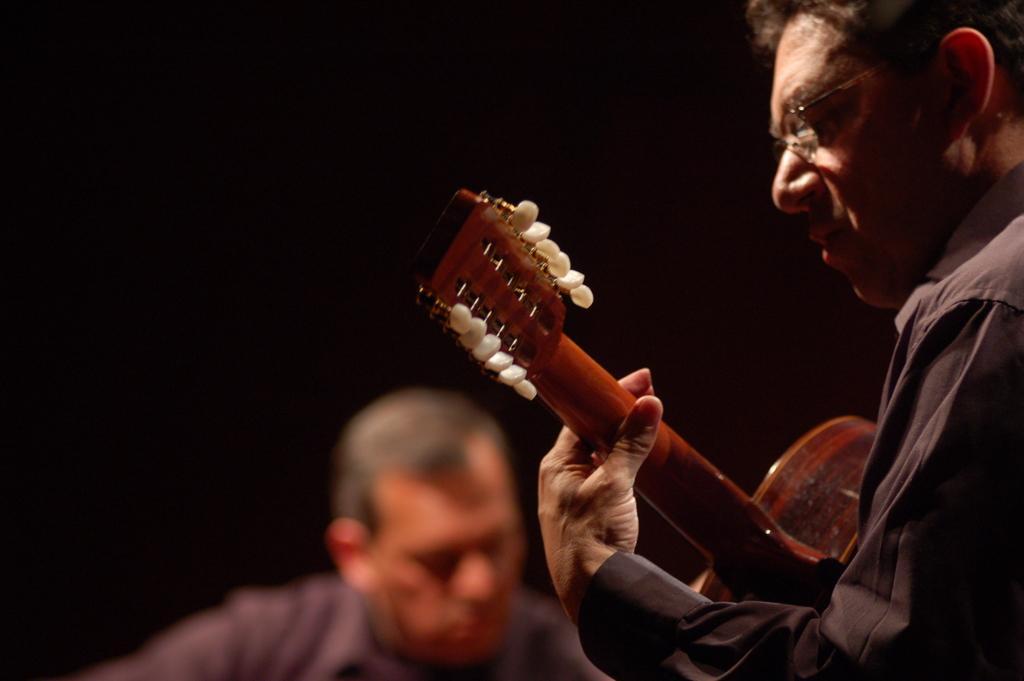Describe this image in one or two sentences. In a picture two people are present and person is playing a guitar and wearing glasses. 